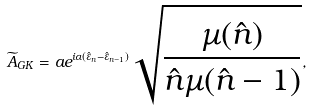Convert formula to latex. <formula><loc_0><loc_0><loc_500><loc_500>\widetilde { A } _ { G K } = a e ^ { i \alpha ( \hat { \varepsilon } _ { n } - \hat { \varepsilon } _ { n - 1 } ) } \sqrt { \frac { \mu ( \hat { n } ) } { \hat { n } \mu ( \hat { n } - 1 ) } } ,</formula> 